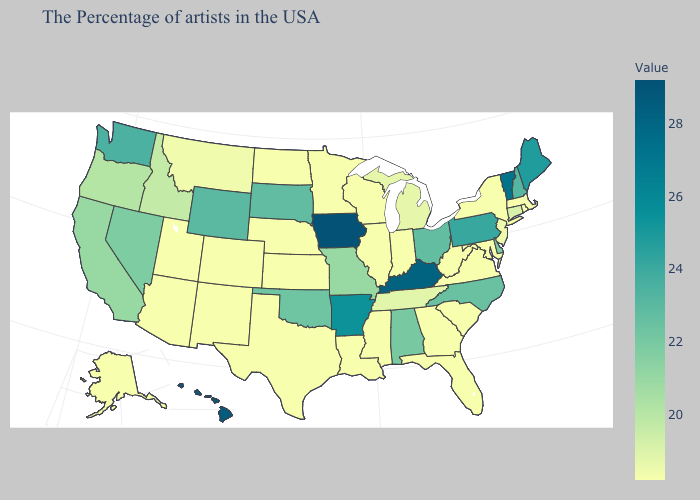Does the map have missing data?
Concise answer only. No. Does Indiana have a lower value than Missouri?
Be succinct. Yes. Does Mississippi have a higher value than Wyoming?
Answer briefly. No. Does New Jersey have the highest value in the Northeast?
Write a very short answer. No. 